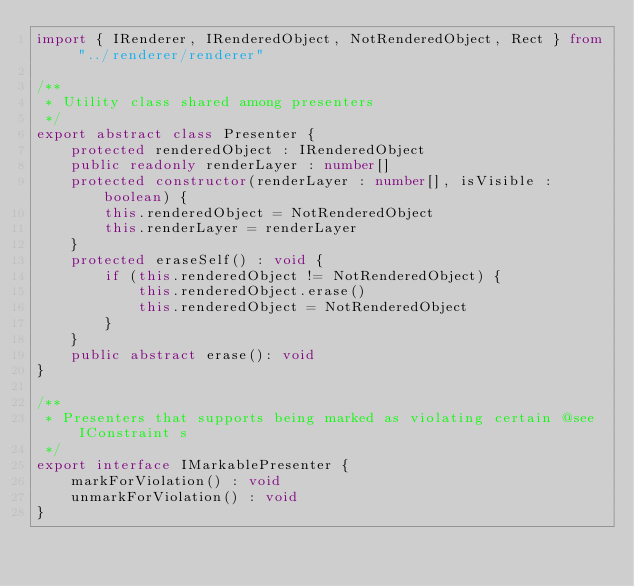<code> <loc_0><loc_0><loc_500><loc_500><_TypeScript_>import { IRenderer, IRenderedObject, NotRenderedObject, Rect } from "../renderer/renderer"

/**
 * Utility class shared among presenters
 */
export abstract class Presenter {
    protected renderedObject : IRenderedObject
    public readonly renderLayer : number[]
    protected constructor(renderLayer : number[], isVisible : boolean) {
        this.renderedObject = NotRenderedObject
        this.renderLayer = renderLayer
    }
    protected eraseSelf() : void {
        if (this.renderedObject != NotRenderedObject) {
            this.renderedObject.erase()
            this.renderedObject = NotRenderedObject
        }
    }
    public abstract erase(): void
}

/**
 * Presenters that supports being marked as violating certain @see IConstraint s
 */
export interface IMarkablePresenter {
    markForViolation() : void
    unmarkForViolation() : void
}</code> 